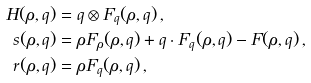Convert formula to latex. <formula><loc_0><loc_0><loc_500><loc_500>H ( \rho , q ) & = q \otimes F _ { q } ( \rho , q ) \, , \\ s ( \rho , q ) & = \rho F _ { \rho } ( \rho , q ) + q \cdot F _ { q } ( \rho , q ) - F ( \rho , q ) \, , \\ r ( \rho , q ) & = \rho F _ { q } ( \rho , q ) \, ,</formula> 